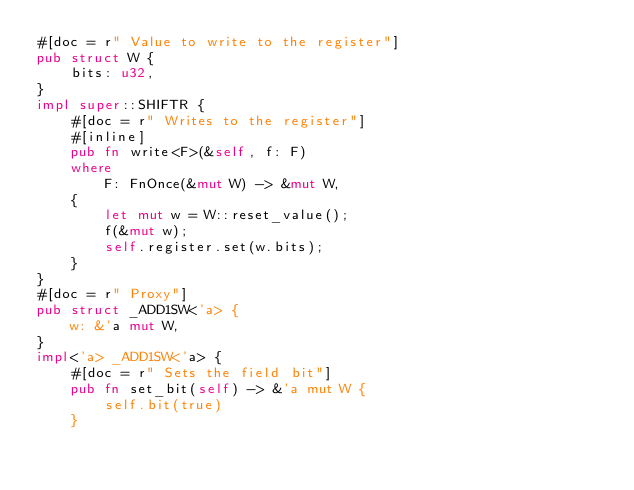<code> <loc_0><loc_0><loc_500><loc_500><_Rust_>#[doc = r" Value to write to the register"]
pub struct W {
    bits: u32,
}
impl super::SHIFTR {
    #[doc = r" Writes to the register"]
    #[inline]
    pub fn write<F>(&self, f: F)
    where
        F: FnOnce(&mut W) -> &mut W,
    {
        let mut w = W::reset_value();
        f(&mut w);
        self.register.set(w.bits);
    }
}
#[doc = r" Proxy"]
pub struct _ADD1SW<'a> {
    w: &'a mut W,
}
impl<'a> _ADD1SW<'a> {
    #[doc = r" Sets the field bit"]
    pub fn set_bit(self) -> &'a mut W {
        self.bit(true)
    }</code> 